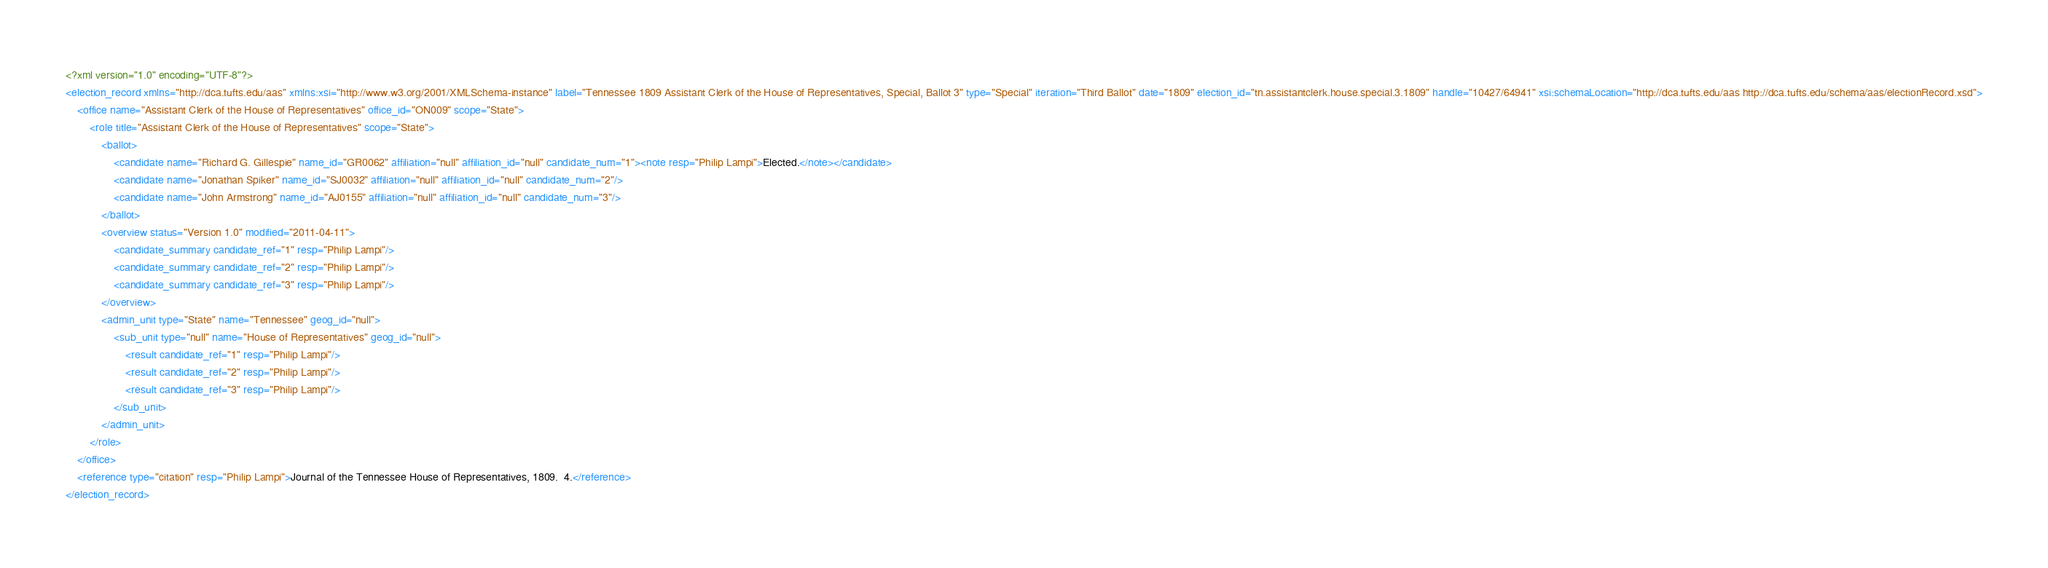Convert code to text. <code><loc_0><loc_0><loc_500><loc_500><_XML_><?xml version="1.0" encoding="UTF-8"?>
<election_record xmlns="http://dca.tufts.edu/aas" xmlns:xsi="http://www.w3.org/2001/XMLSchema-instance" label="Tennessee 1809 Assistant Clerk of the House of Representatives, Special, Ballot 3" type="Special" iteration="Third Ballot" date="1809" election_id="tn.assistantclerk.house.special.3.1809" handle="10427/64941" xsi:schemaLocation="http://dca.tufts.edu/aas http://dca.tufts.edu/schema/aas/electionRecord.xsd">
    <office name="Assistant Clerk of the House of Representatives" office_id="ON009" scope="State">
        <role title="Assistant Clerk of the House of Representatives" scope="State">
            <ballot>
                <candidate name="Richard G. Gillespie" name_id="GR0062" affiliation="null" affiliation_id="null" candidate_num="1"><note resp="Philip Lampi">Elected.</note></candidate>
                <candidate name="Jonathan Spiker" name_id="SJ0032" affiliation="null" affiliation_id="null" candidate_num="2"/>
                <candidate name="John Armstrong" name_id="AJ0155" affiliation="null" affiliation_id="null" candidate_num="3"/>
            </ballot>
            <overview status="Version 1.0" modified="2011-04-11">
                <candidate_summary candidate_ref="1" resp="Philip Lampi"/>
                <candidate_summary candidate_ref="2" resp="Philip Lampi"/>
                <candidate_summary candidate_ref="3" resp="Philip Lampi"/>
            </overview>
            <admin_unit type="State" name="Tennessee" geog_id="null">
                <sub_unit type="null" name="House of Representatives" geog_id="null">
                    <result candidate_ref="1" resp="Philip Lampi"/>
                    <result candidate_ref="2" resp="Philip Lampi"/>
                    <result candidate_ref="3" resp="Philip Lampi"/>
                </sub_unit>
            </admin_unit>
        </role>
    </office>
    <reference type="citation" resp="Philip Lampi">Journal of the Tennessee House of Representatives, 1809.  4.</reference>
</election_record></code> 